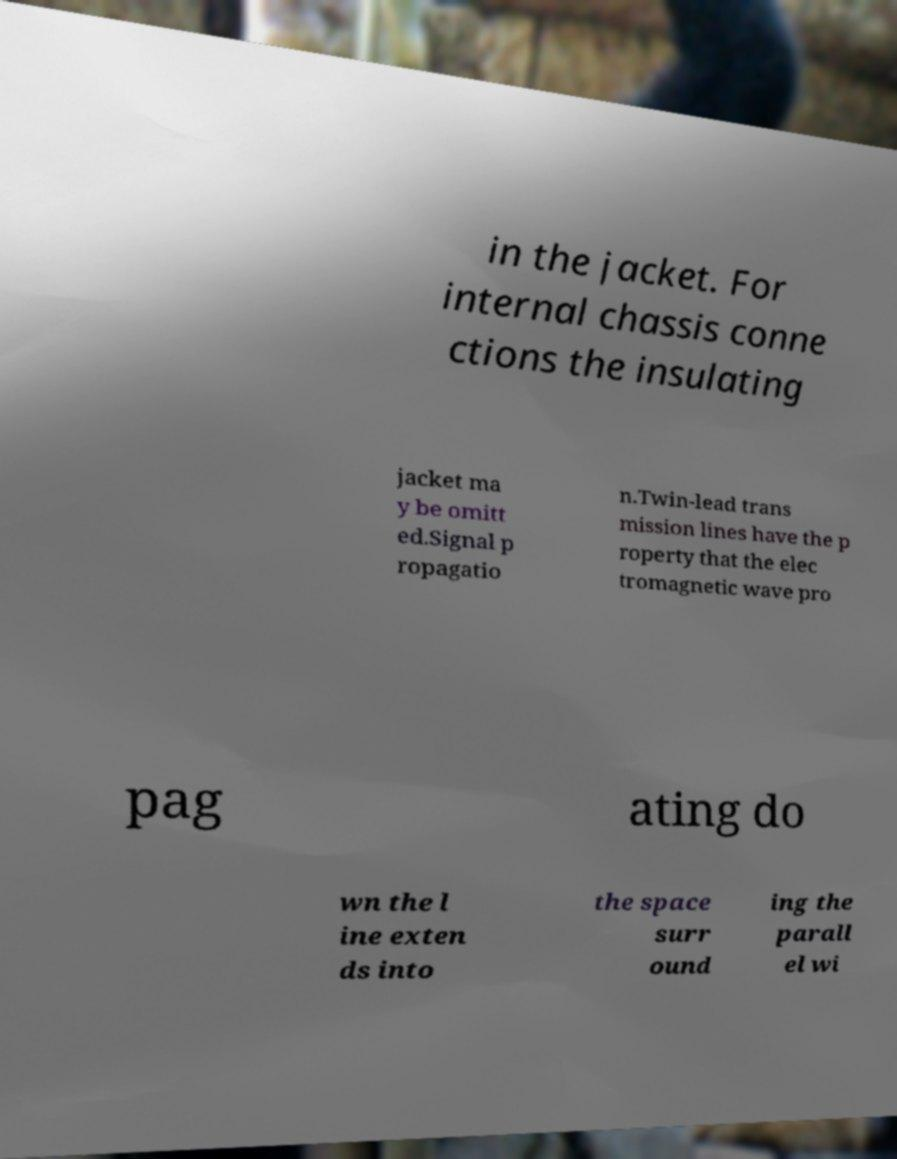Please read and relay the text visible in this image. What does it say? in the jacket. For internal chassis conne ctions the insulating jacket ma y be omitt ed.Signal p ropagatio n.Twin-lead trans mission lines have the p roperty that the elec tromagnetic wave pro pag ating do wn the l ine exten ds into the space surr ound ing the parall el wi 